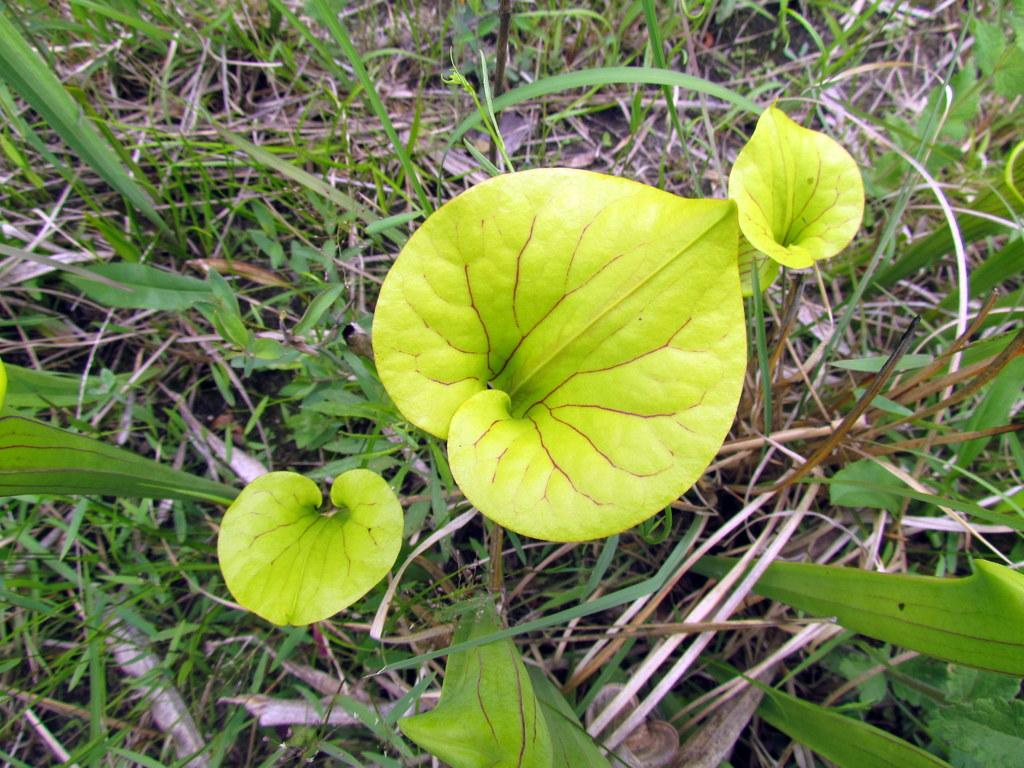How many leaves can be seen in the image? There are three light green leaves in the image. What else is present in the image besides the leaves? There are plants and dry grass in the image. What type of soap is being used to clean the plants in the image? There is no soap or cleaning activity depicted in the image; it only shows three light green leaves, plants, and dry grass. 